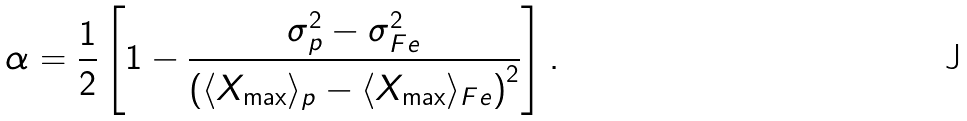<formula> <loc_0><loc_0><loc_500><loc_500>\alpha = \frac { 1 } { 2 } \left [ 1 - \frac { \sigma _ { p } ^ { 2 } - \sigma ^ { 2 } _ { F e } } { \left ( \langle X _ { \max } \rangle _ { p } - \langle X _ { \max } \rangle _ { F e } \right ) ^ { 2 } } \right ] .</formula> 